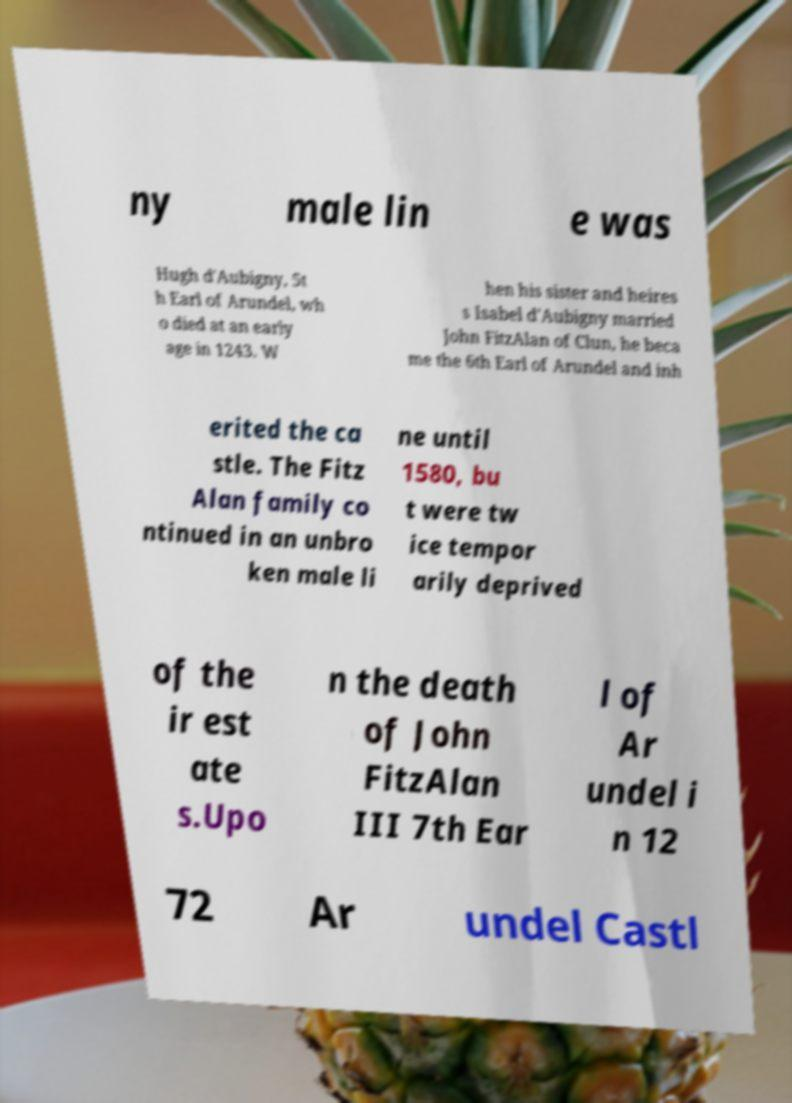For documentation purposes, I need the text within this image transcribed. Could you provide that? ny male lin e was Hugh d'Aubigny, 5t h Earl of Arundel, wh o died at an early age in 1243. W hen his sister and heires s Isabel d'Aubigny married John FitzAlan of Clun, he beca me the 6th Earl of Arundel and inh erited the ca stle. The Fitz Alan family co ntinued in an unbro ken male li ne until 1580, bu t were tw ice tempor arily deprived of the ir est ate s.Upo n the death of John FitzAlan III 7th Ear l of Ar undel i n 12 72 Ar undel Castl 